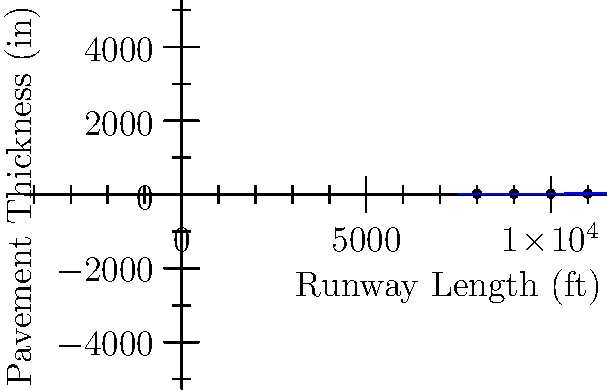An Air Force base is planning to upgrade its runway to accommodate larger aircraft. The graph shows the relationship between runway length and required pavement thickness for different types of aircraft. If the base needs to extend the runway to 10,500 ft, what would be the approximate required pavement thickness in inches? To solve this problem, we need to follow these steps:

1. Understand the graph:
   - The x-axis represents runway length in feet
   - The y-axis represents pavement thickness in inches
   - The blue line represents the relationship between length and thickness

2. Identify the linear relationship:
   - The line appears to follow the equation $y = mx + b$
   - We can estimate $m$ (slope) and $b$ (y-intercept) from the graph

3. Estimate the equation:
   - The line passes through approximately (8000, 18) and (11000, 24)
   - Slope $m = \frac{24 - 18}{11000 - 8000} = \frac{6}{3000} = 0.002$
   - Y-intercept $b$ can be found using a point: $18 = 0.002(8000) + b$
   - Solving for $b$: $b = 18 - 16 = 2$
   - Equation: $y = 0.002x + 2$

4. Calculate the thickness for 10,500 ft:
   - Substitute $x = 10500$ into the equation
   - $y = 0.002(10500) + 2$
   - $y = 21 + 2 = 23$

Therefore, the approximate required pavement thickness for a 10,500 ft runway is 23 inches.
Answer: 23 inches 